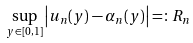<formula> <loc_0><loc_0><loc_500><loc_500>\sup _ { y \in [ 0 , 1 ] } \left | u _ { n } ( y ) - \alpha _ { n } ( y ) \right | = \colon R _ { n }</formula> 